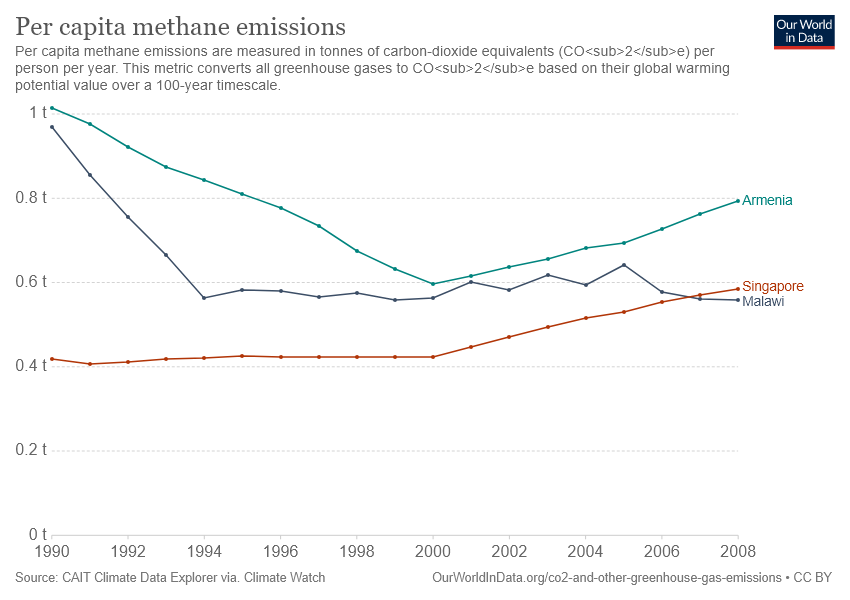List a handful of essential elements in this visual. According to recent data, Armenia has the highest level of methane emissions per capita among all countries. Malawi has had lower greenhouse gas emissions than Singapore for the past two years. 